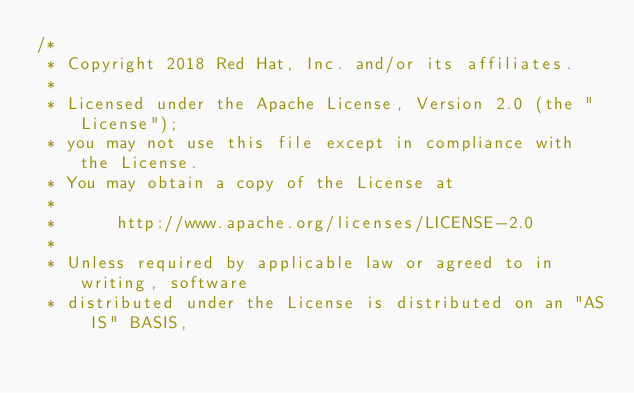<code> <loc_0><loc_0><loc_500><loc_500><_Java_>/*
 * Copyright 2018 Red Hat, Inc. and/or its affiliates.
 *
 * Licensed under the Apache License, Version 2.0 (the "License");
 * you may not use this file except in compliance with the License.
 * You may obtain a copy of the License at
 *
 *      http://www.apache.org/licenses/LICENSE-2.0
 *
 * Unless required by applicable law or agreed to in writing, software
 * distributed under the License is distributed on an "AS IS" BASIS,</code> 